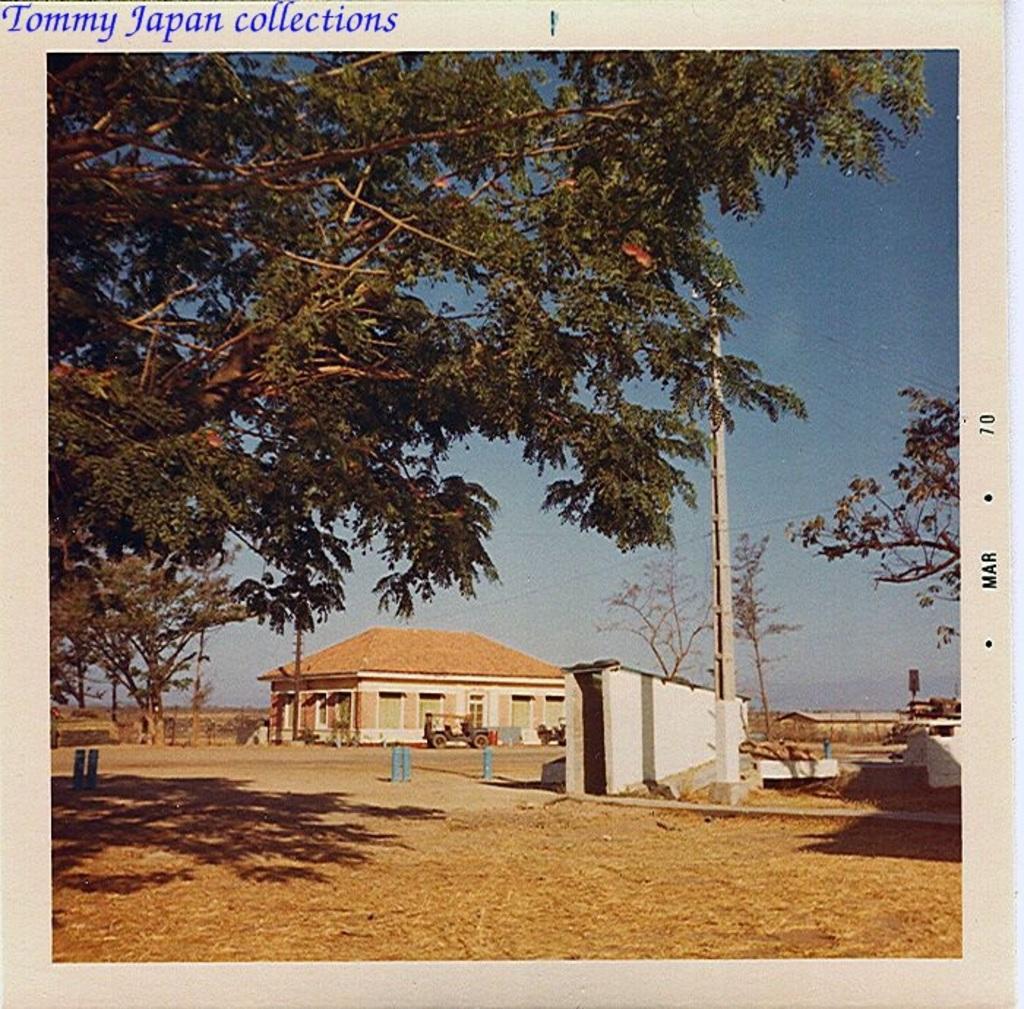How would you summarize this image in a sentence or two? On the left there are trees. In the center of the picture there are vehicles, house, wall, trees and other objects. On the right there are wall, bags, trees and other objects. In the foreground there is dust. Sky is sunny. At the top there is text. 